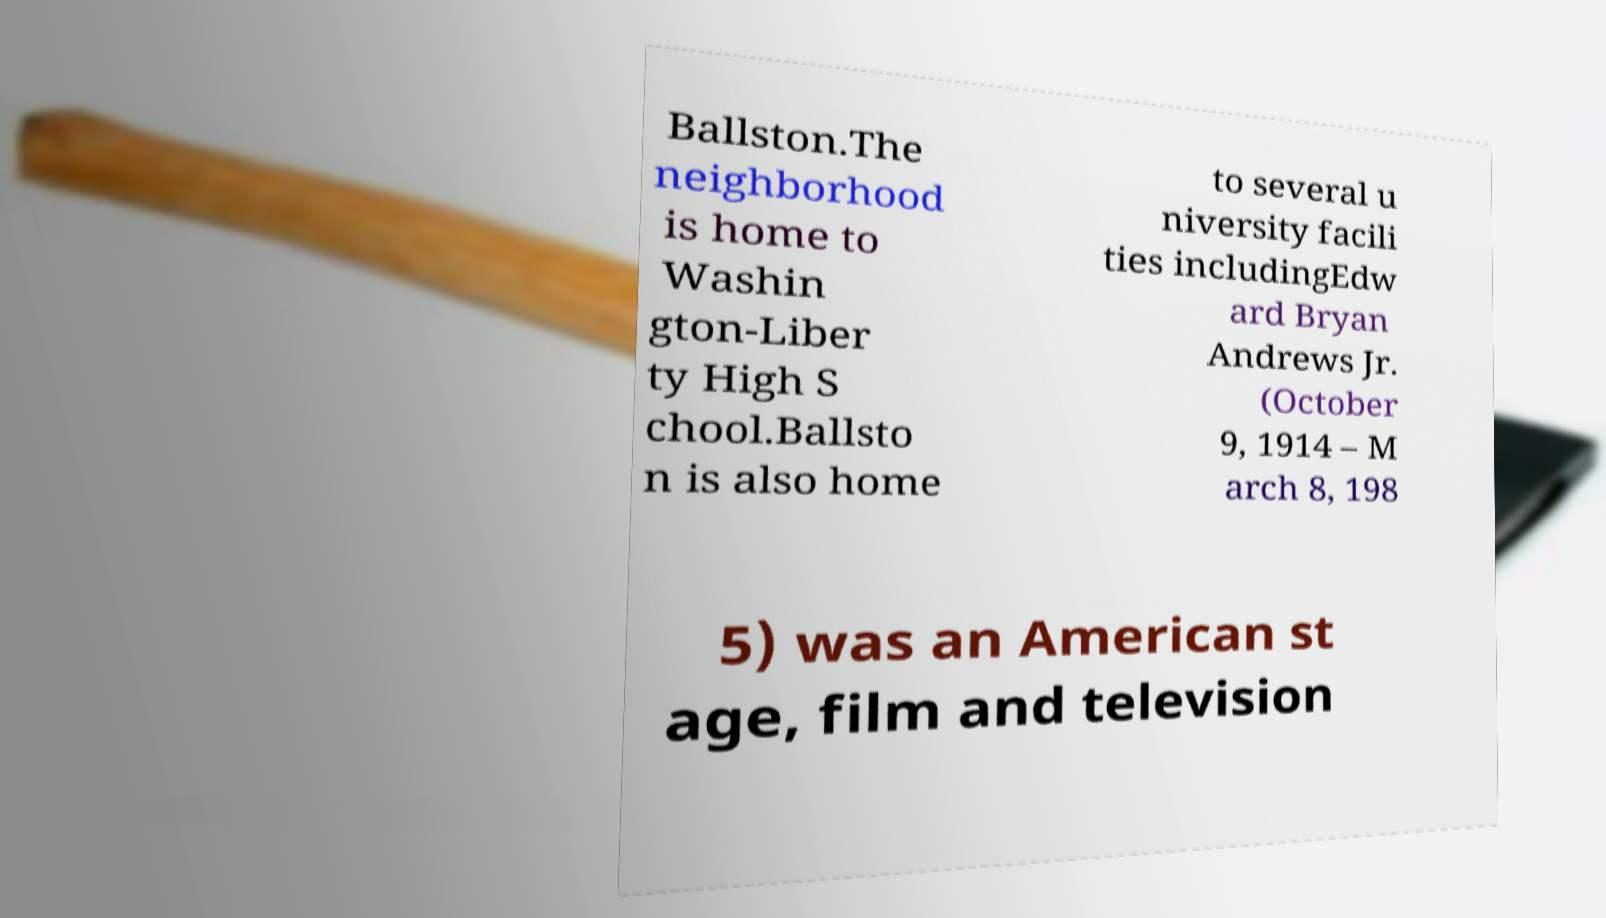What messages or text are displayed in this image? I need them in a readable, typed format. Ballston.The neighborhood is home to Washin gton-Liber ty High S chool.Ballsto n is also home to several u niversity facili ties includingEdw ard Bryan Andrews Jr. (October 9, 1914 – M arch 8, 198 5) was an American st age, film and television 